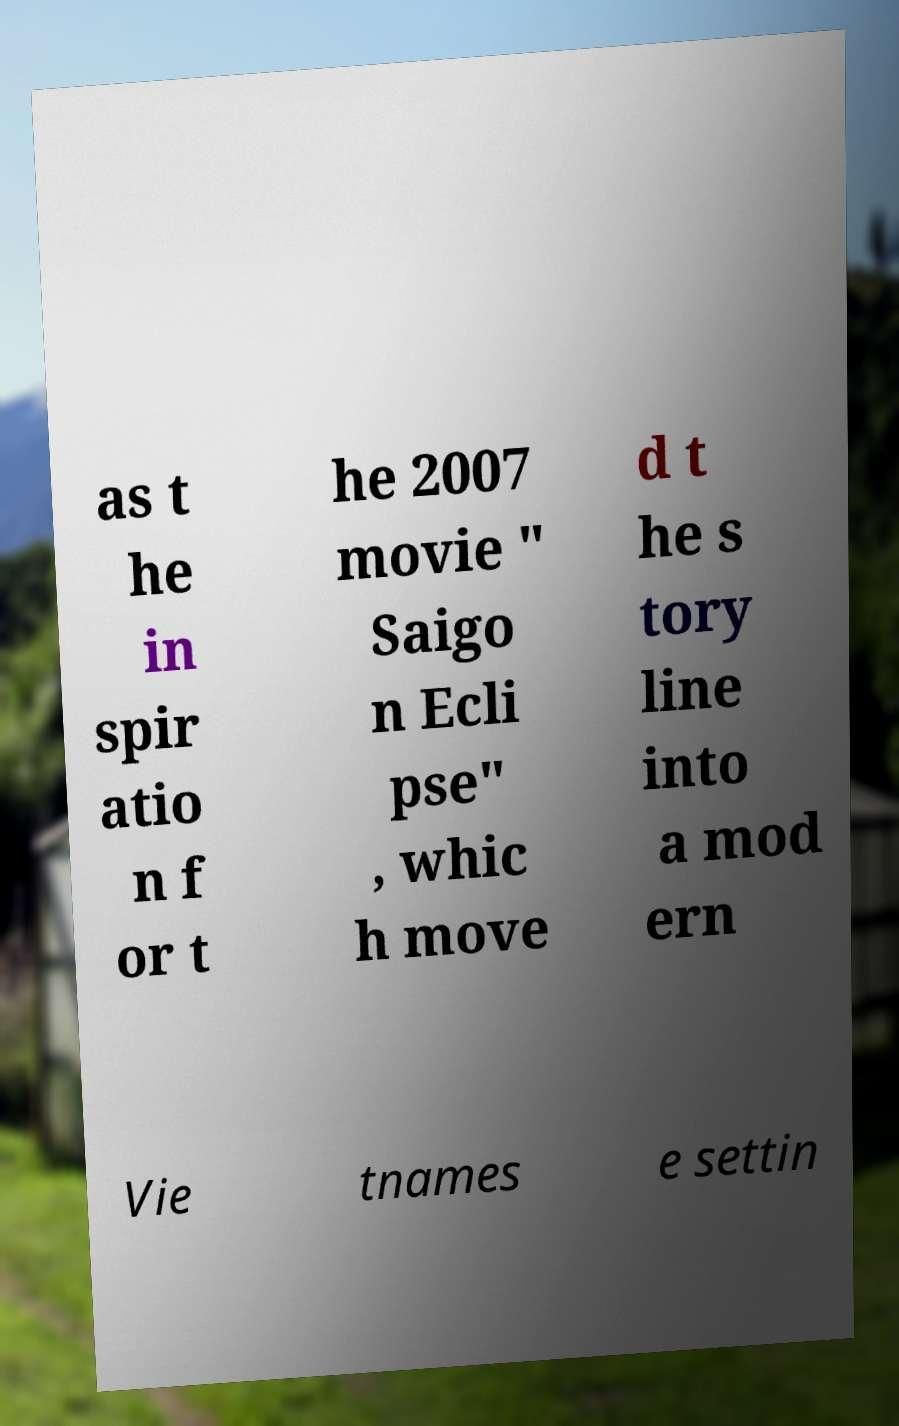There's text embedded in this image that I need extracted. Can you transcribe it verbatim? as t he in spir atio n f or t he 2007 movie " Saigo n Ecli pse" , whic h move d t he s tory line into a mod ern Vie tnames e settin 